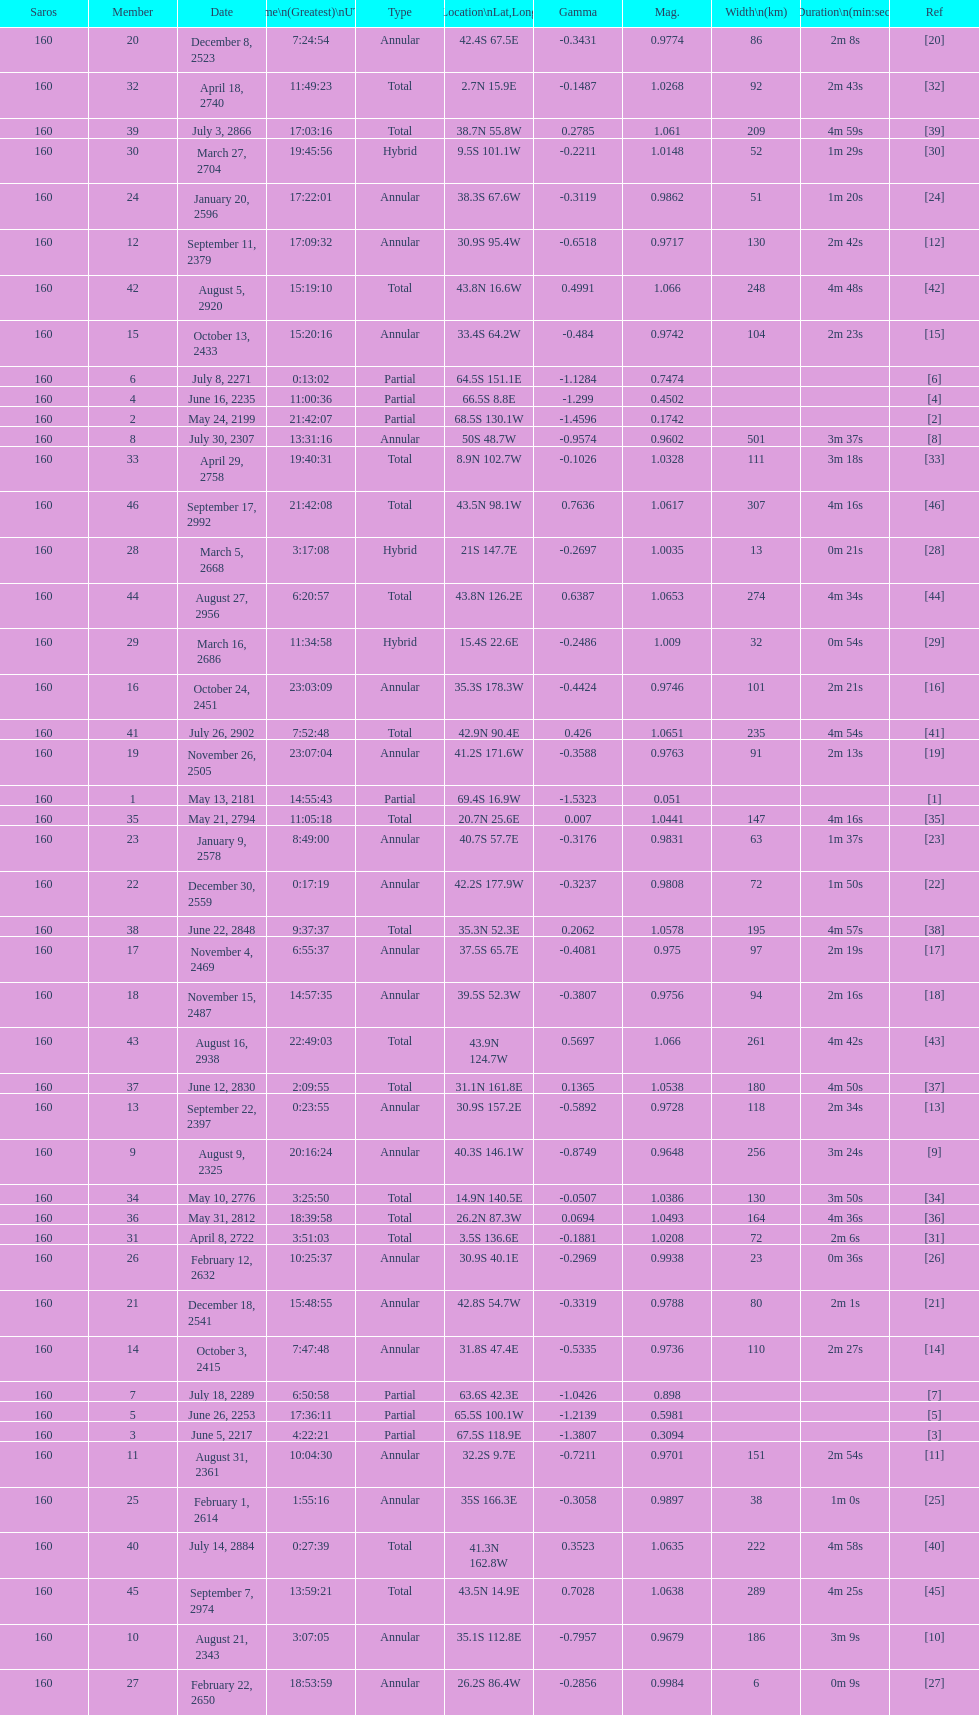Name one that has the same latitude as member number 12. 13. 